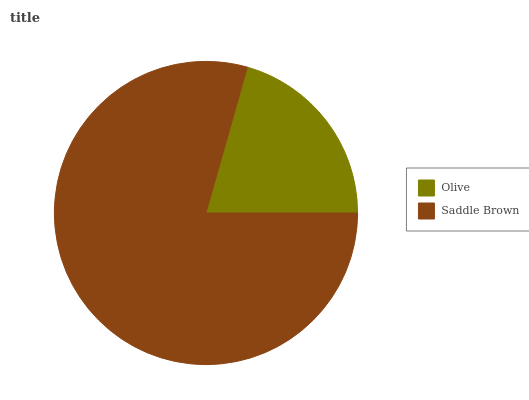Is Olive the minimum?
Answer yes or no. Yes. Is Saddle Brown the maximum?
Answer yes or no. Yes. Is Saddle Brown the minimum?
Answer yes or no. No. Is Saddle Brown greater than Olive?
Answer yes or no. Yes. Is Olive less than Saddle Brown?
Answer yes or no. Yes. Is Olive greater than Saddle Brown?
Answer yes or no. No. Is Saddle Brown less than Olive?
Answer yes or no. No. Is Saddle Brown the high median?
Answer yes or no. Yes. Is Olive the low median?
Answer yes or no. Yes. Is Olive the high median?
Answer yes or no. No. Is Saddle Brown the low median?
Answer yes or no. No. 